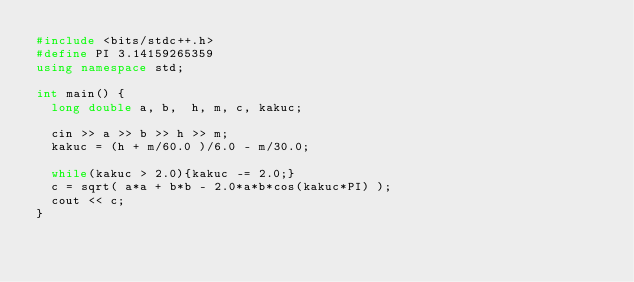Convert code to text. <code><loc_0><loc_0><loc_500><loc_500><_C++_>#include <bits/stdc++.h>
#define PI 3.14159265359
using namespace std;
 
int main() {
  long double a, b,  h, m, c, kakuc;

  cin >> a >> b >> h >> m;
  kakuc = (h + m/60.0 )/6.0 - m/30.0;

  while(kakuc > 2.0){kakuc -= 2.0;}
  c = sqrt( a*a + b*b - 2.0*a*b*cos(kakuc*PI) );
  cout << c;
}</code> 